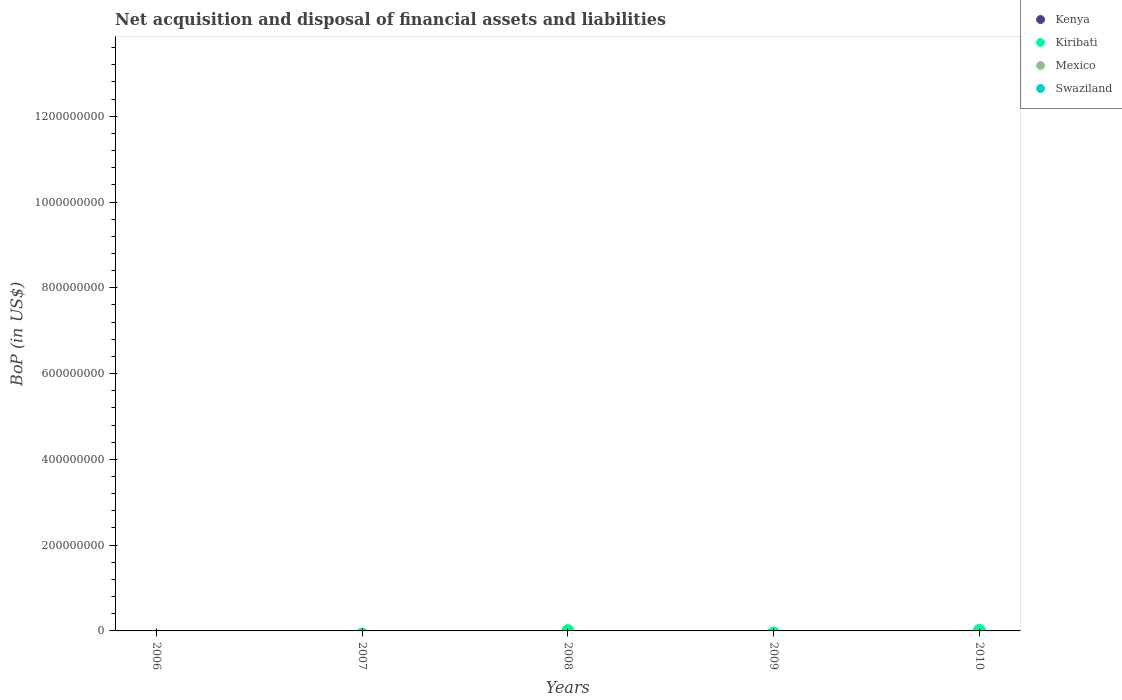How many different coloured dotlines are there?
Provide a succinct answer. 1. Is the number of dotlines equal to the number of legend labels?
Your answer should be compact. No. What is the Balance of Payments in Kiribati in 2008?
Give a very brief answer. 7.43e+05. Across all years, what is the maximum Balance of Payments in Kiribati?
Your response must be concise. 1.46e+06. Across all years, what is the minimum Balance of Payments in Kiribati?
Keep it short and to the point. 0. What is the total Balance of Payments in Kiribati in the graph?
Provide a succinct answer. 2.20e+06. What is the difference between the highest and the lowest Balance of Payments in Kiribati?
Provide a short and direct response. 1.46e+06. Is it the case that in every year, the sum of the Balance of Payments in Mexico and Balance of Payments in Kenya  is greater than the Balance of Payments in Swaziland?
Keep it short and to the point. No. Is the Balance of Payments in Swaziland strictly less than the Balance of Payments in Kenya over the years?
Provide a short and direct response. No. How many years are there in the graph?
Offer a very short reply. 5. Are the values on the major ticks of Y-axis written in scientific E-notation?
Ensure brevity in your answer.  No. Does the graph contain any zero values?
Provide a short and direct response. Yes. Does the graph contain grids?
Your answer should be very brief. No. Where does the legend appear in the graph?
Make the answer very short. Top right. How are the legend labels stacked?
Provide a short and direct response. Vertical. What is the title of the graph?
Offer a very short reply. Net acquisition and disposal of financial assets and liabilities. What is the label or title of the X-axis?
Your answer should be very brief. Years. What is the label or title of the Y-axis?
Your response must be concise. BoP (in US$). What is the BoP (in US$) in Kiribati in 2006?
Ensure brevity in your answer.  0. What is the BoP (in US$) of Swaziland in 2006?
Provide a succinct answer. 0. What is the BoP (in US$) of Kenya in 2007?
Keep it short and to the point. 0. What is the BoP (in US$) in Kiribati in 2007?
Ensure brevity in your answer.  0. What is the BoP (in US$) of Swaziland in 2007?
Your answer should be compact. 0. What is the BoP (in US$) in Kiribati in 2008?
Give a very brief answer. 7.43e+05. What is the BoP (in US$) of Swaziland in 2008?
Make the answer very short. 0. What is the BoP (in US$) of Kenya in 2010?
Make the answer very short. 0. What is the BoP (in US$) of Kiribati in 2010?
Give a very brief answer. 1.46e+06. What is the BoP (in US$) of Mexico in 2010?
Provide a short and direct response. 0. Across all years, what is the maximum BoP (in US$) in Kiribati?
Give a very brief answer. 1.46e+06. Across all years, what is the minimum BoP (in US$) of Kiribati?
Provide a short and direct response. 0. What is the total BoP (in US$) in Kiribati in the graph?
Provide a succinct answer. 2.20e+06. What is the total BoP (in US$) of Mexico in the graph?
Give a very brief answer. 0. What is the difference between the BoP (in US$) of Kiribati in 2008 and that in 2010?
Give a very brief answer. -7.16e+05. What is the average BoP (in US$) of Kenya per year?
Your response must be concise. 0. What is the average BoP (in US$) of Kiribati per year?
Give a very brief answer. 4.40e+05. What is the ratio of the BoP (in US$) of Kiribati in 2008 to that in 2010?
Provide a short and direct response. 0.51. What is the difference between the highest and the lowest BoP (in US$) in Kiribati?
Your answer should be very brief. 1.46e+06. 